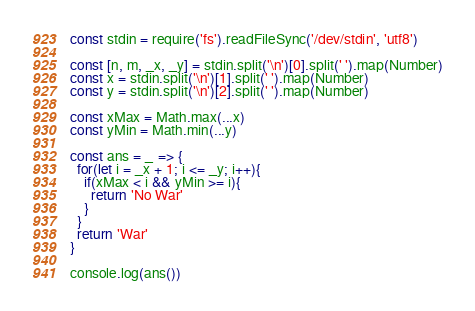Convert code to text. <code><loc_0><loc_0><loc_500><loc_500><_TypeScript_>const stdin = require('fs').readFileSync('/dev/stdin', 'utf8')

const [n, m, _x, _y] = stdin.split('\n')[0].split(' ').map(Number)
const x = stdin.split('\n')[1].split(' ').map(Number)
const y = stdin.split('\n')[2].split(' ').map(Number)

const xMax = Math.max(...x)
const yMin = Math.min(...y)

const ans = _ => {
  for(let i = _x + 1; i <= _y; i++){
    if(xMax < i && yMin >= i){
      return 'No War'
    }
  }
  return 'War'  
}

console.log(ans())</code> 